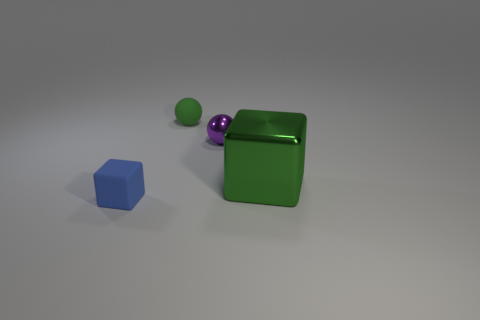Add 4 small matte blocks. How many objects exist? 8 Add 2 small green things. How many small green things exist? 3 Subtract 0 cyan balls. How many objects are left? 4 Subtract all small brown matte spheres. Subtract all blue rubber blocks. How many objects are left? 3 Add 4 matte blocks. How many matte blocks are left? 5 